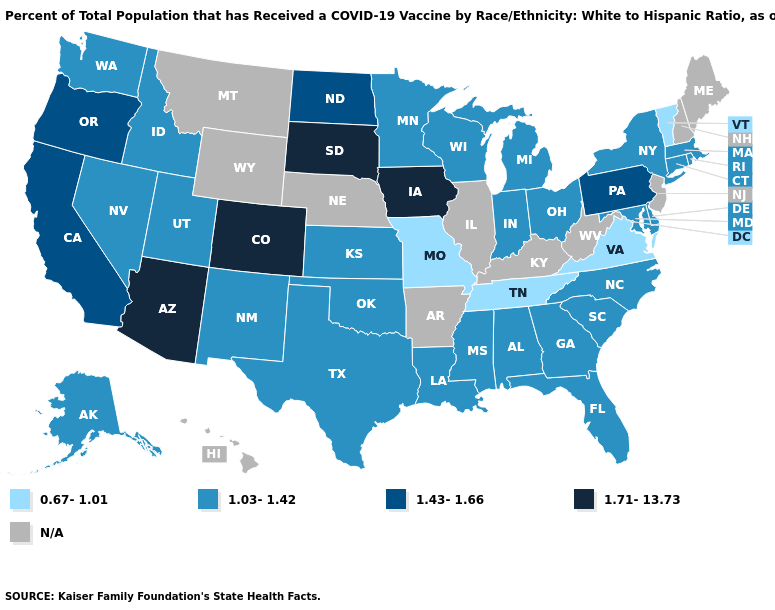Among the states that border New Mexico , does Utah have the lowest value?
Be succinct. Yes. What is the lowest value in states that border Kentucky?
Write a very short answer. 0.67-1.01. Does the first symbol in the legend represent the smallest category?
Concise answer only. Yes. Which states have the highest value in the USA?
Answer briefly. Arizona, Colorado, Iowa, South Dakota. Name the states that have a value in the range 1.71-13.73?
Write a very short answer. Arizona, Colorado, Iowa, South Dakota. What is the highest value in the USA?
Write a very short answer. 1.71-13.73. Name the states that have a value in the range 0.67-1.01?
Short answer required. Missouri, Tennessee, Vermont, Virginia. Is the legend a continuous bar?
Answer briefly. No. What is the value of New Jersey?
Quick response, please. N/A. What is the value of Minnesota?
Keep it brief. 1.03-1.42. What is the highest value in states that border Vermont?
Be succinct. 1.03-1.42. Name the states that have a value in the range 1.43-1.66?
Answer briefly. California, North Dakota, Oregon, Pennsylvania. Among the states that border Michigan , which have the highest value?
Be succinct. Indiana, Ohio, Wisconsin. 